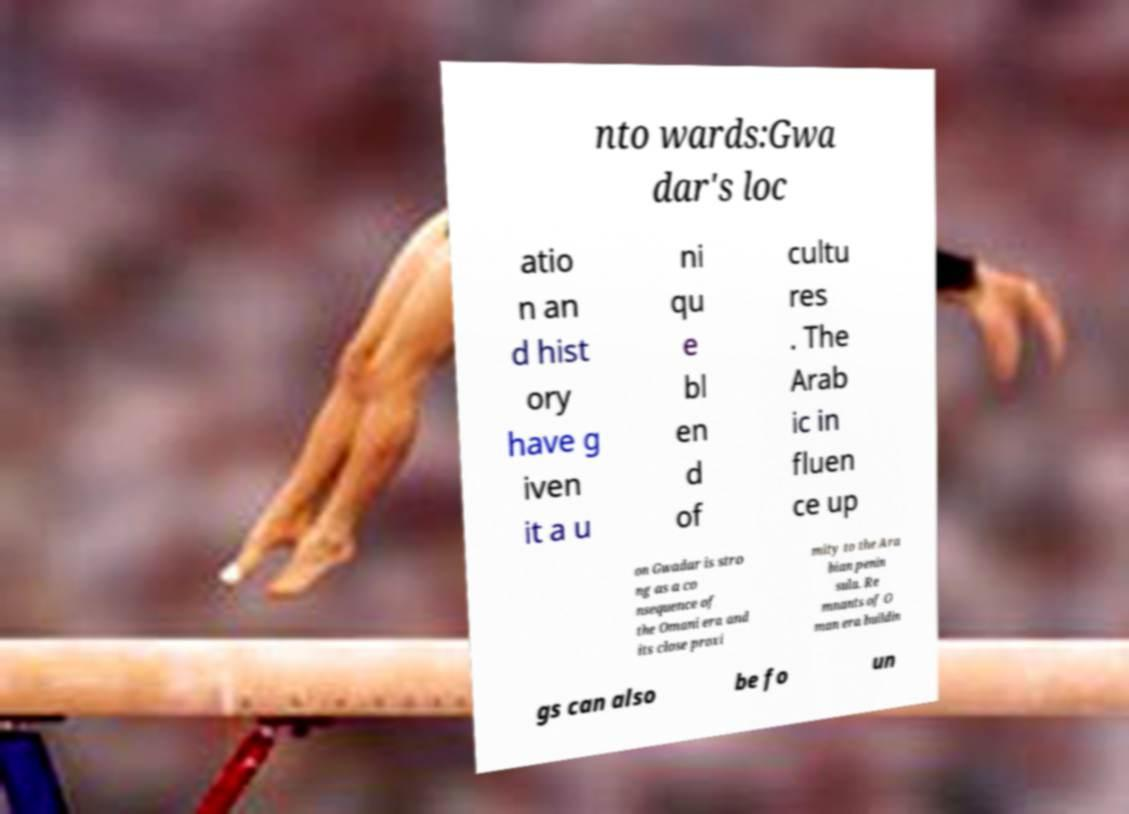There's text embedded in this image that I need extracted. Can you transcribe it verbatim? nto wards:Gwa dar's loc atio n an d hist ory have g iven it a u ni qu e bl en d of cultu res . The Arab ic in fluen ce up on Gwadar is stro ng as a co nsequence of the Omani era and its close proxi mity to the Ara bian penin sula. Re mnants of O man era buildin gs can also be fo un 